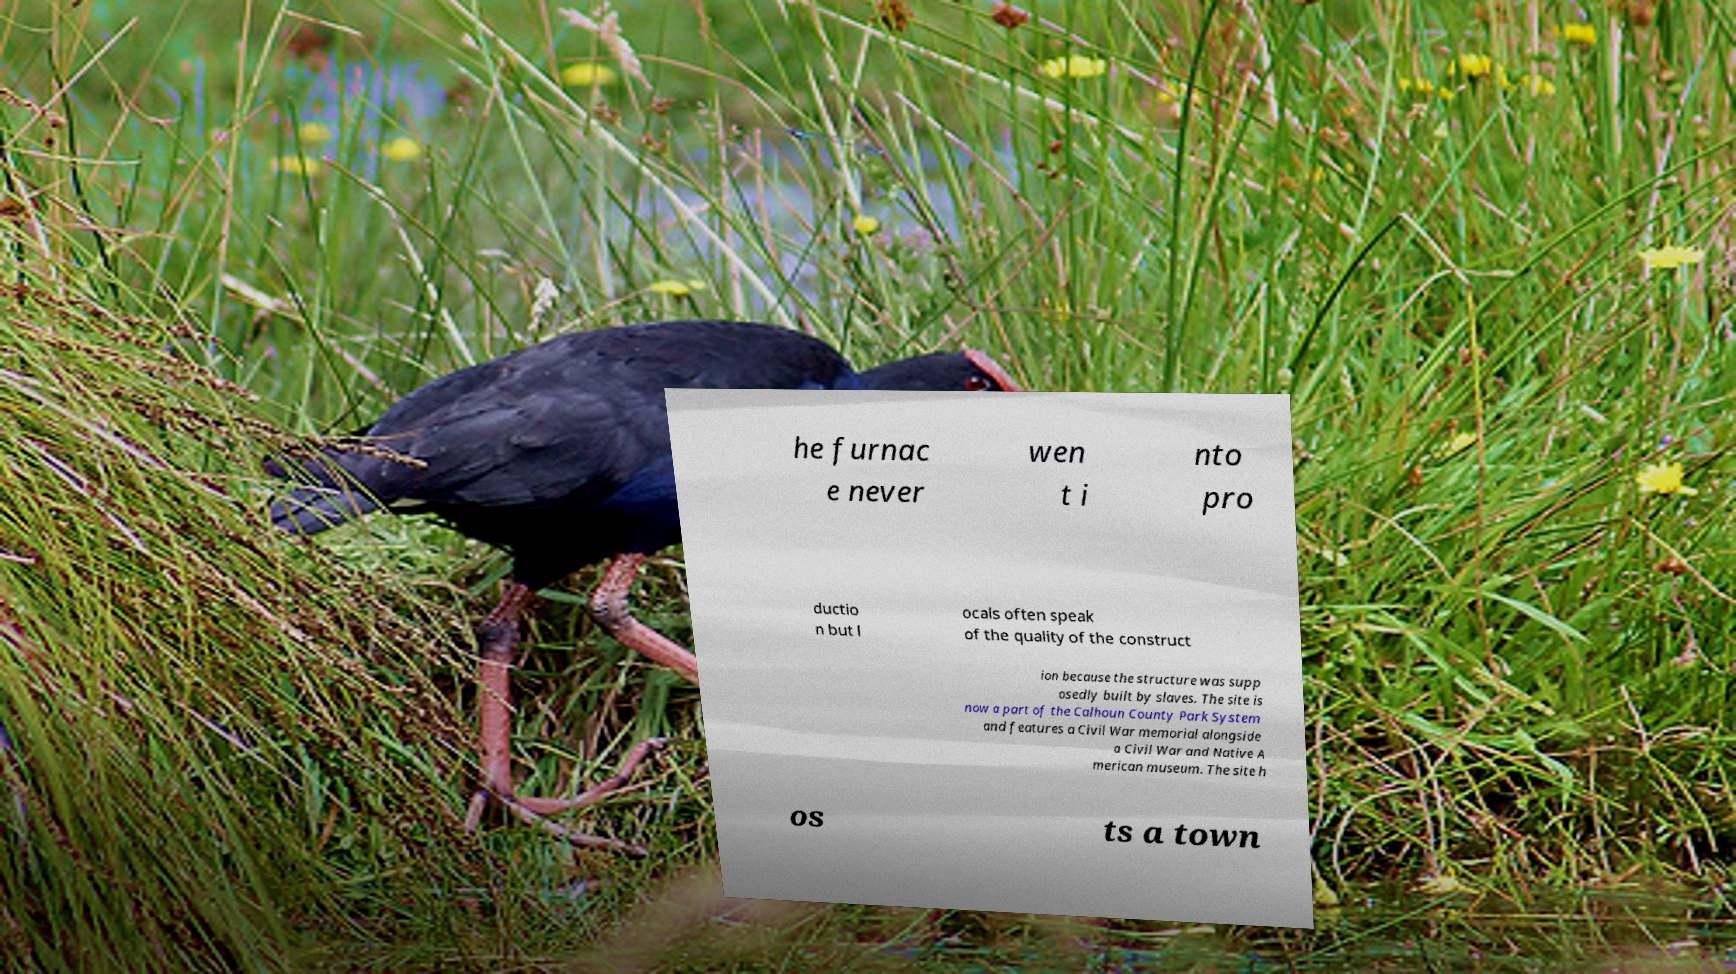Can you read and provide the text displayed in the image?This photo seems to have some interesting text. Can you extract and type it out for me? he furnac e never wen t i nto pro ductio n but l ocals often speak of the quality of the construct ion because the structure was supp osedly built by slaves. The site is now a part of the Calhoun County Park System and features a Civil War memorial alongside a Civil War and Native A merican museum. The site h os ts a town 